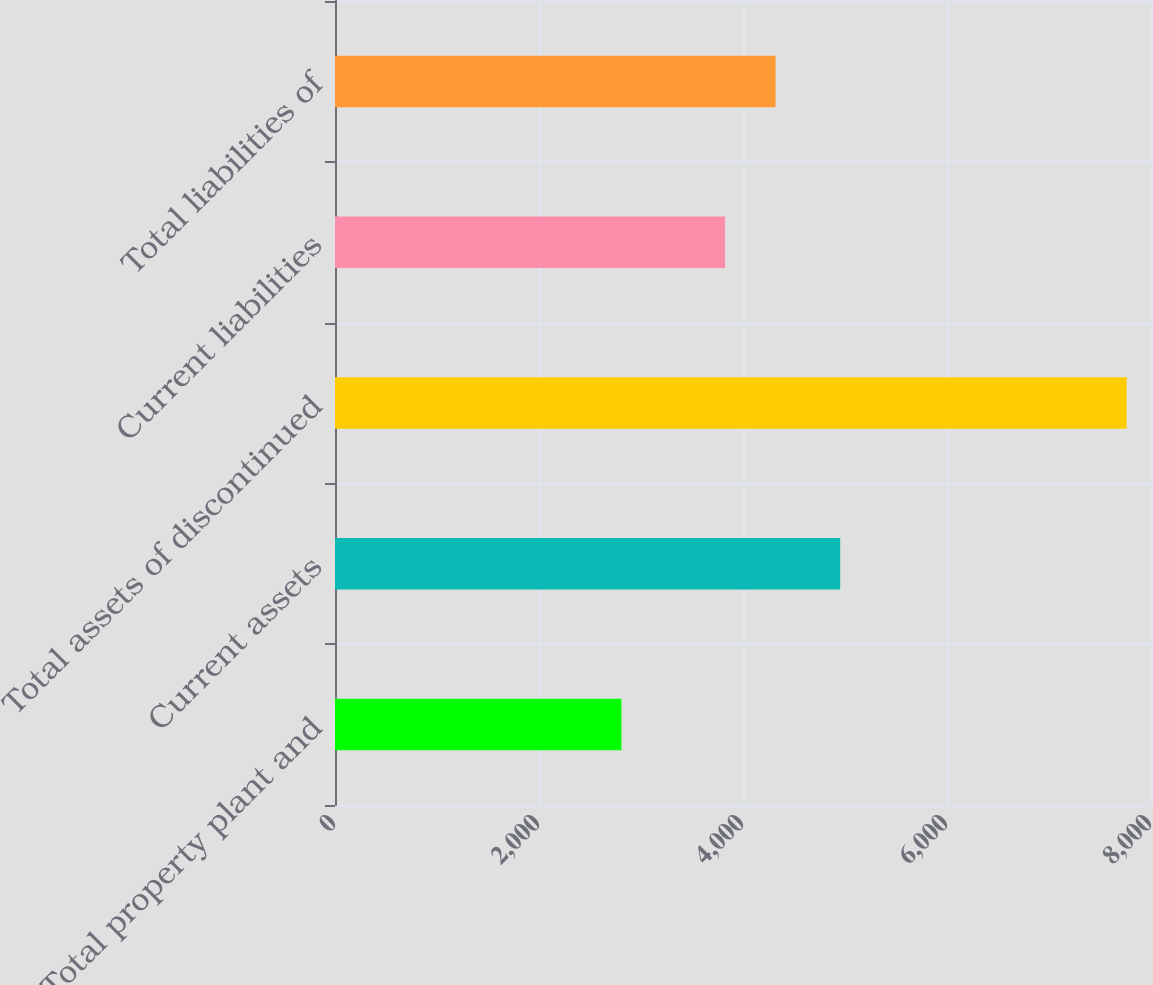Convert chart. <chart><loc_0><loc_0><loc_500><loc_500><bar_chart><fcel>Total property plant and<fcel>Current assets<fcel>Total assets of discontinued<fcel>Current liabilities<fcel>Total liabilities of<nl><fcel>2808<fcel>4953<fcel>7761<fcel>3824<fcel>4319.3<nl></chart> 